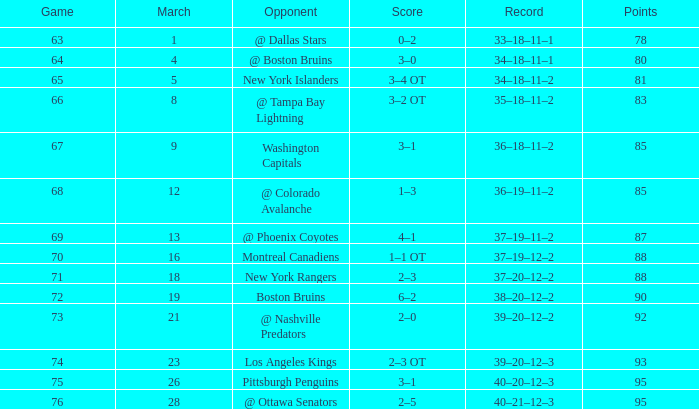Which Game is the highest one that has Points smaller than 92, and a Score of 1–3? 68.0. 